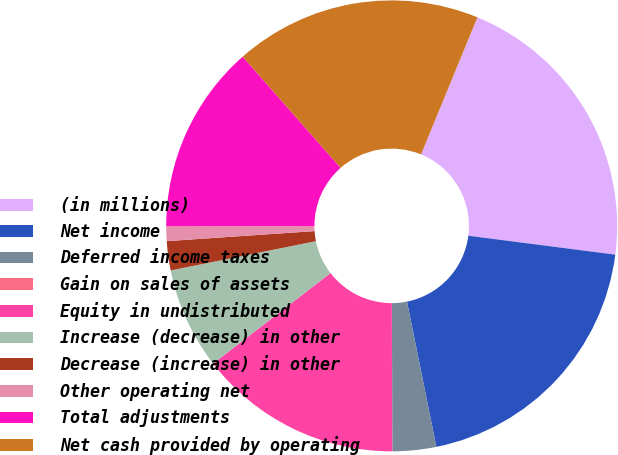Convert chart to OTSL. <chart><loc_0><loc_0><loc_500><loc_500><pie_chart><fcel>(in millions)<fcel>Net income<fcel>Deferred income taxes<fcel>Gain on sales of assets<fcel>Equity in undistributed<fcel>Increase (decrease) in other<fcel>Decrease (increase) in other<fcel>Other operating net<fcel>Total adjustments<fcel>Net cash provided by operating<nl><fcel>20.83%<fcel>19.79%<fcel>3.13%<fcel>0.01%<fcel>14.58%<fcel>7.29%<fcel>2.09%<fcel>1.05%<fcel>13.54%<fcel>17.7%<nl></chart> 